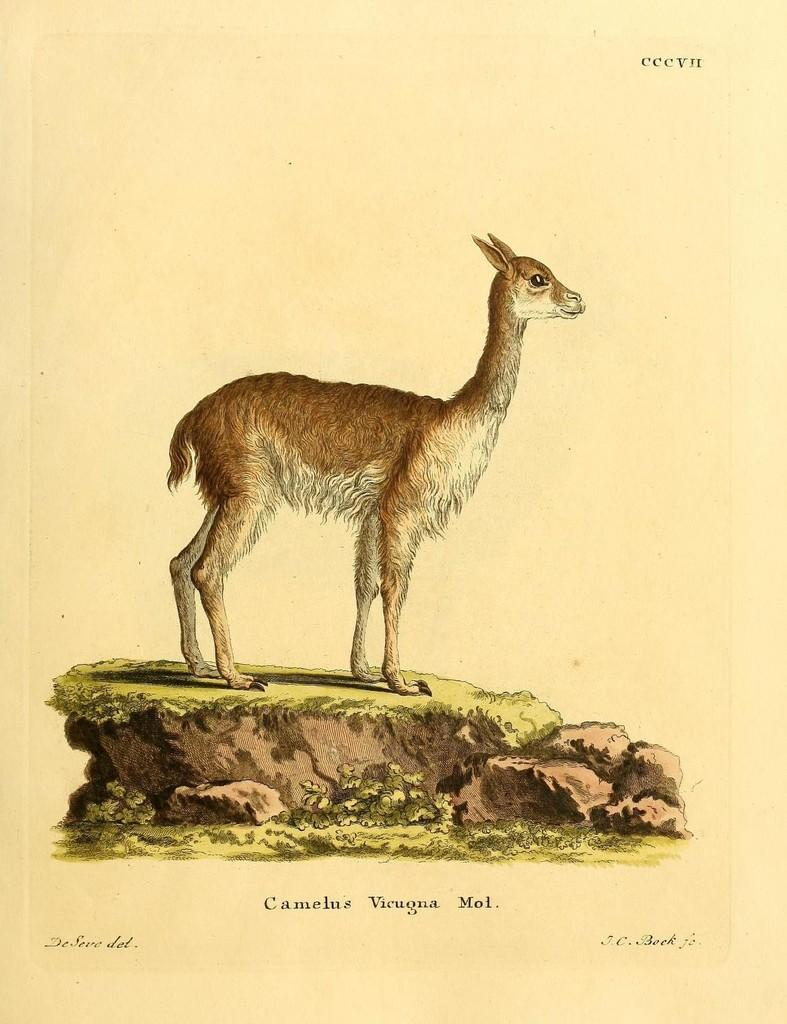What is the main subject of the image? The image contains a painting. What is depicted in the painting? The painting features an animal. Can you describe the setting in which the animal is situated in the painting? The animal is standing on a stone in the painting. What type of credit card is the animal holding in the painting? There is no credit card present in the painting; it features an animal standing on a stone. What type of apparel is the animal wearing in the painting? There is no apparel present in the painting; the animal is depicted as standing on a stone. 